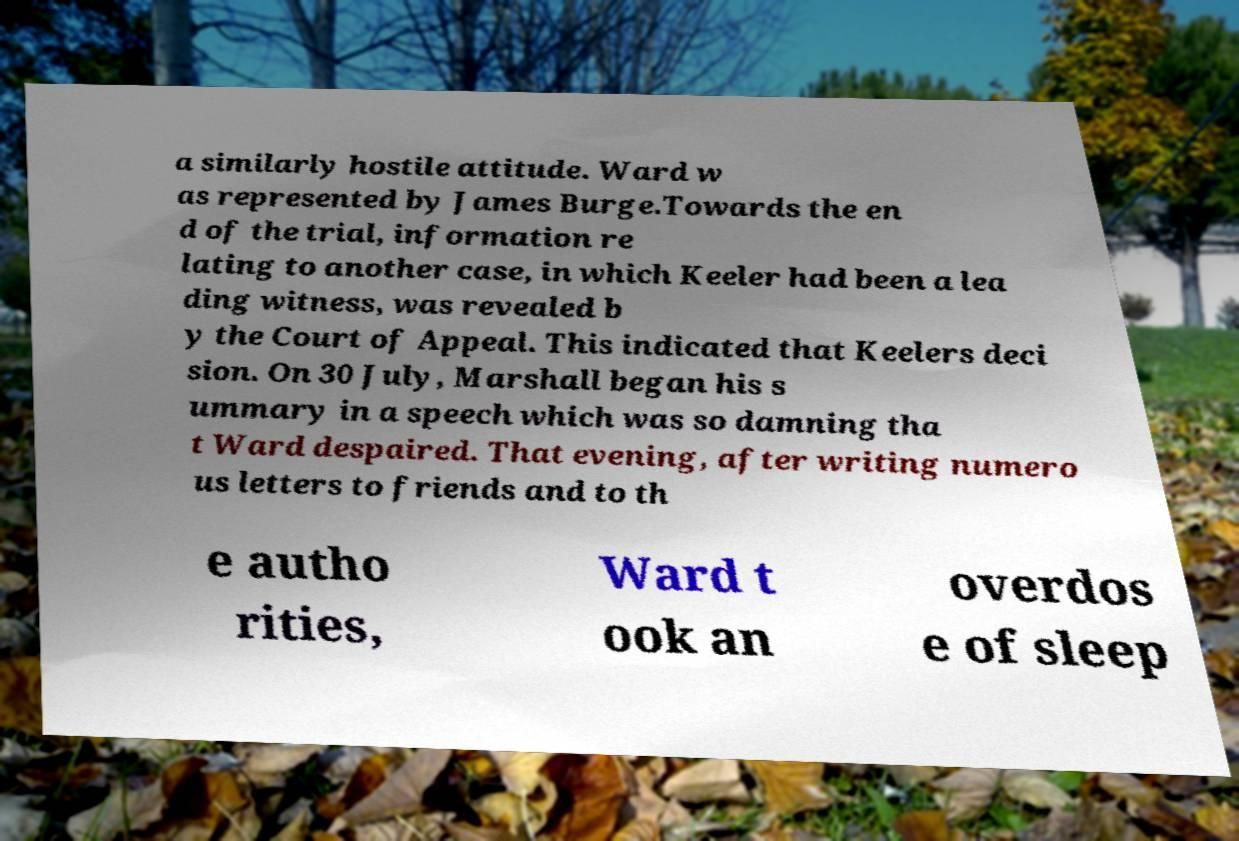What messages or text are displayed in this image? I need them in a readable, typed format. a similarly hostile attitude. Ward w as represented by James Burge.Towards the en d of the trial, information re lating to another case, in which Keeler had been a lea ding witness, was revealed b y the Court of Appeal. This indicated that Keelers deci sion. On 30 July, Marshall began his s ummary in a speech which was so damning tha t Ward despaired. That evening, after writing numero us letters to friends and to th e autho rities, Ward t ook an overdos e of sleep 